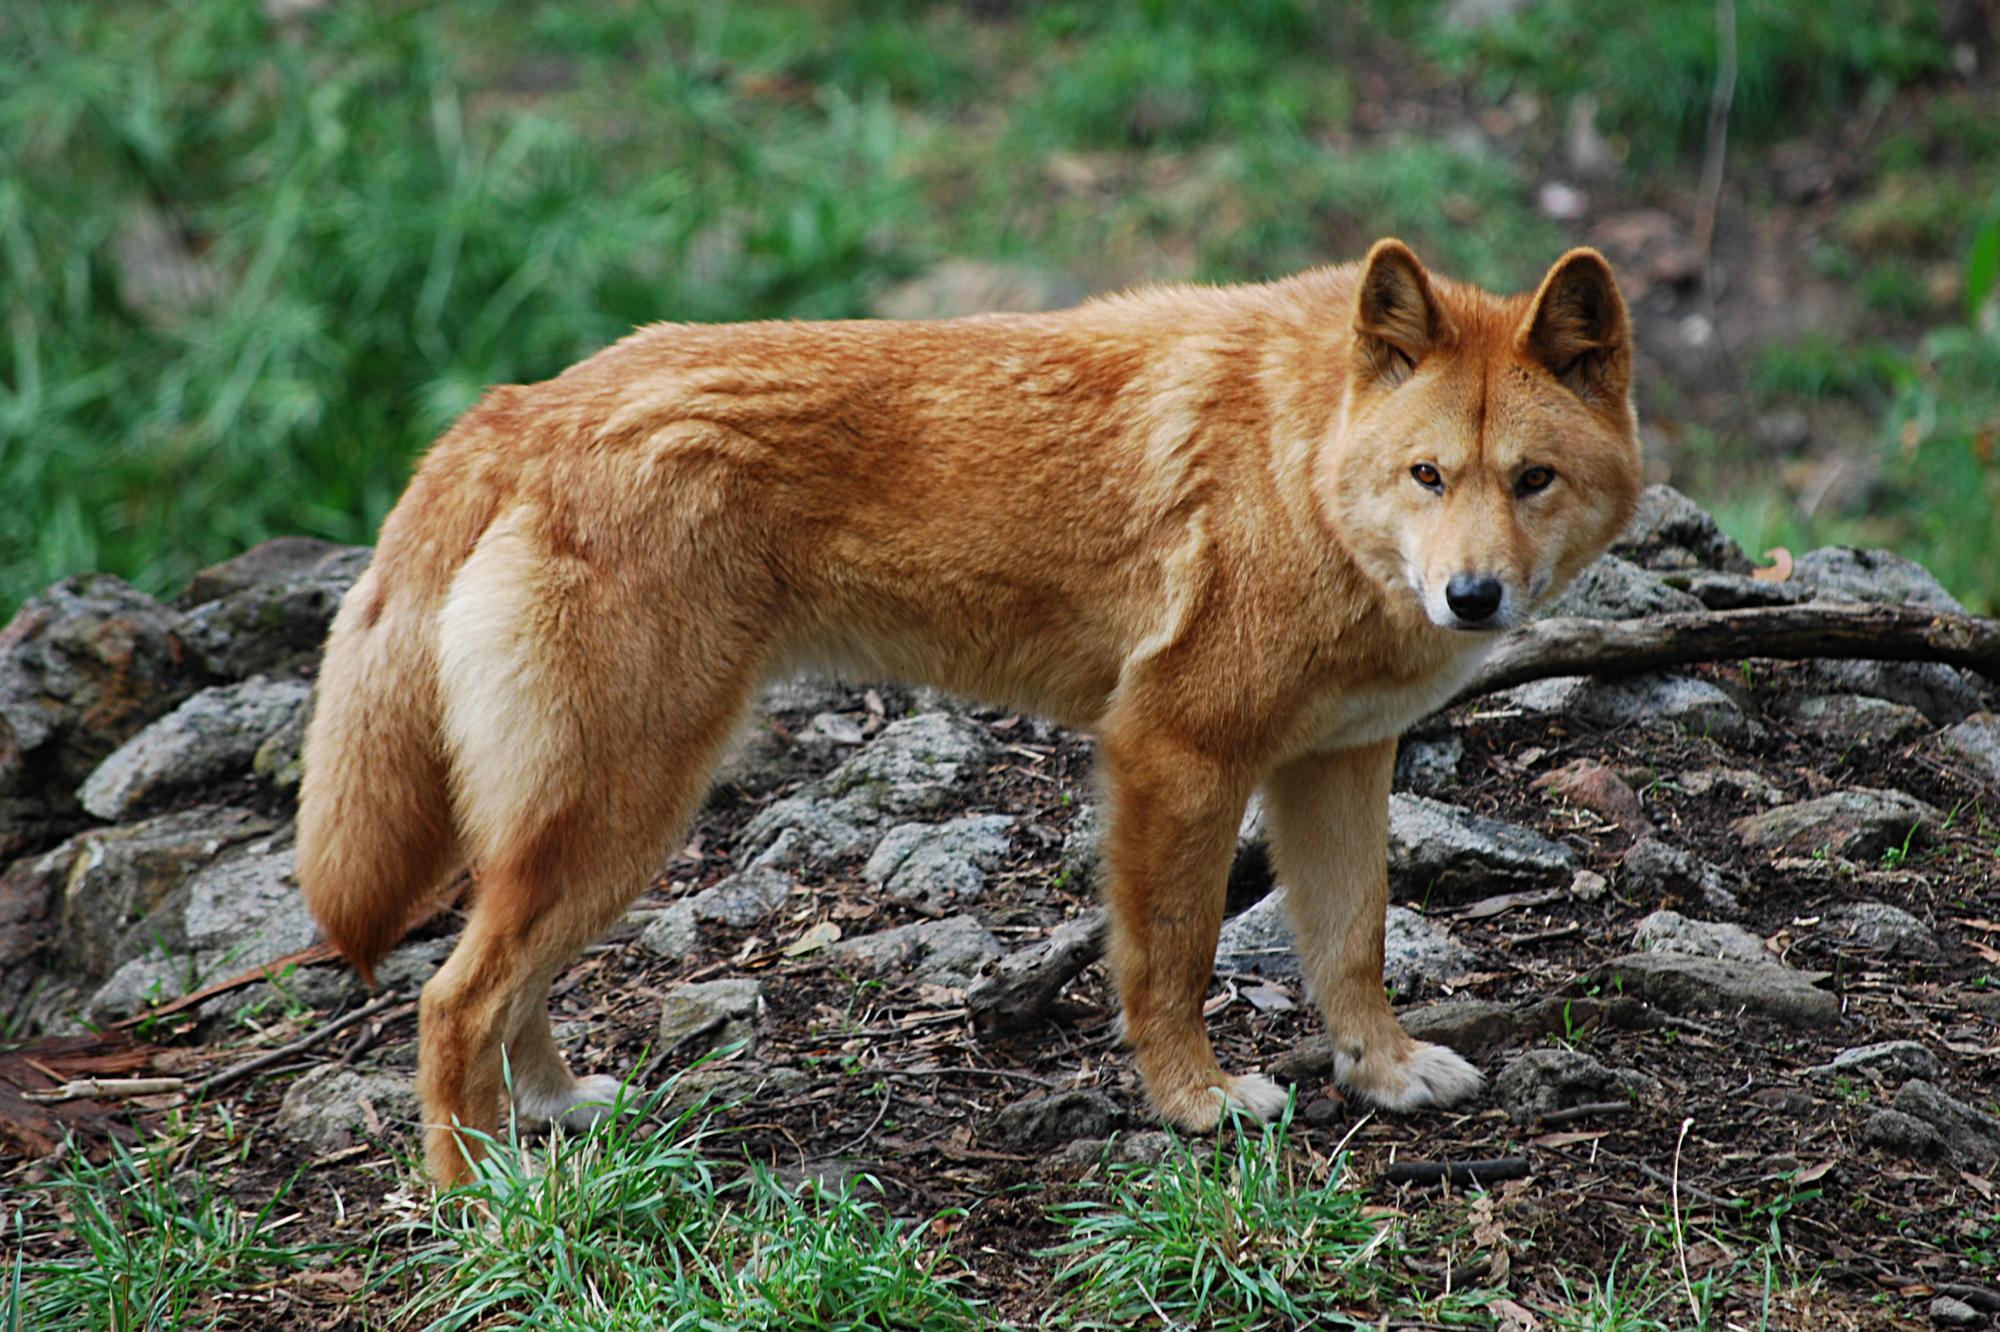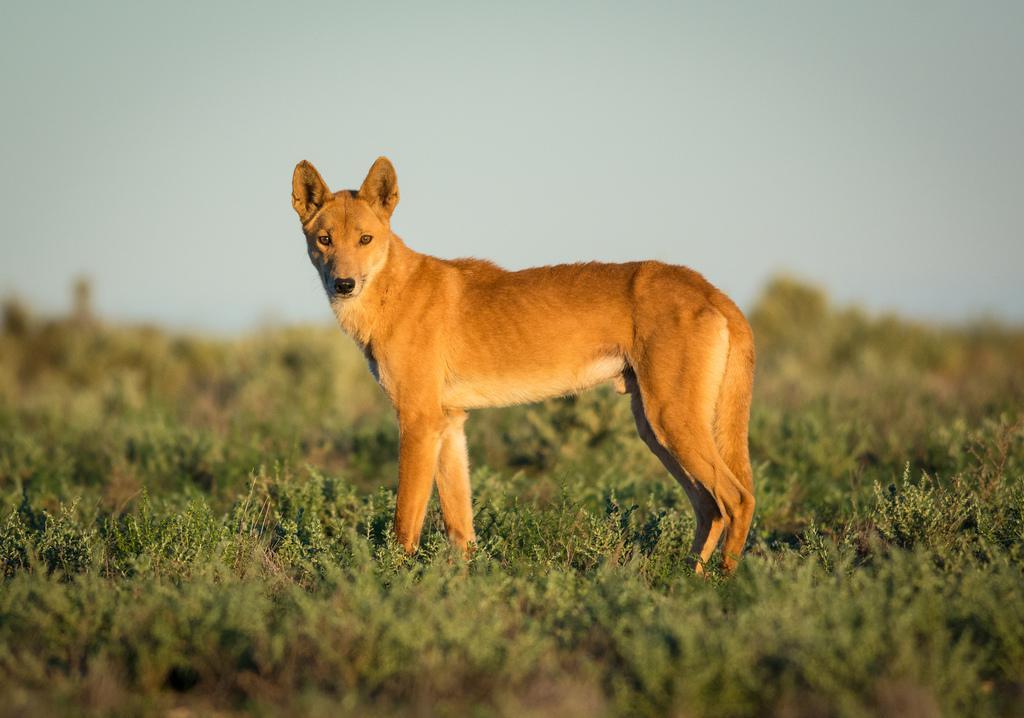The first image is the image on the left, the second image is the image on the right. For the images shown, is this caption "The dog in the image on the left has its eyes closed." true? Answer yes or no. No. The first image is the image on the left, the second image is the image on the right. For the images shown, is this caption "The dog on the left is sleepy-looking." true? Answer yes or no. No. 